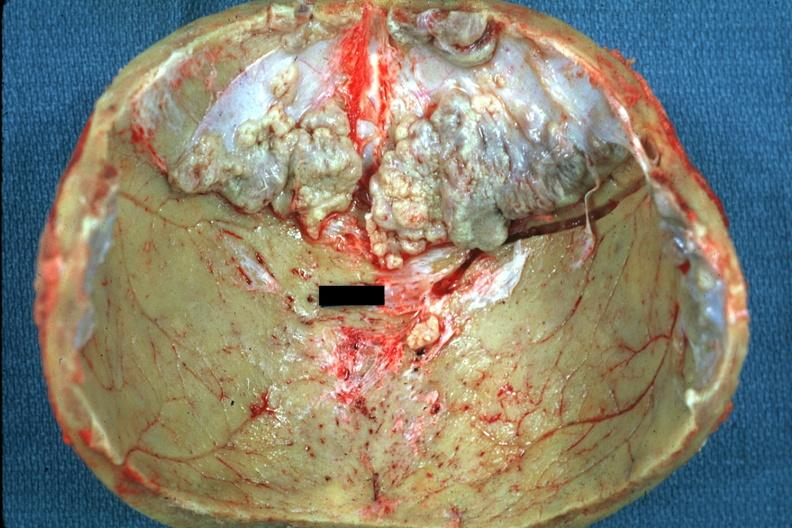what is present?
Answer the question using a single word or phrase. Bone, calvarium 